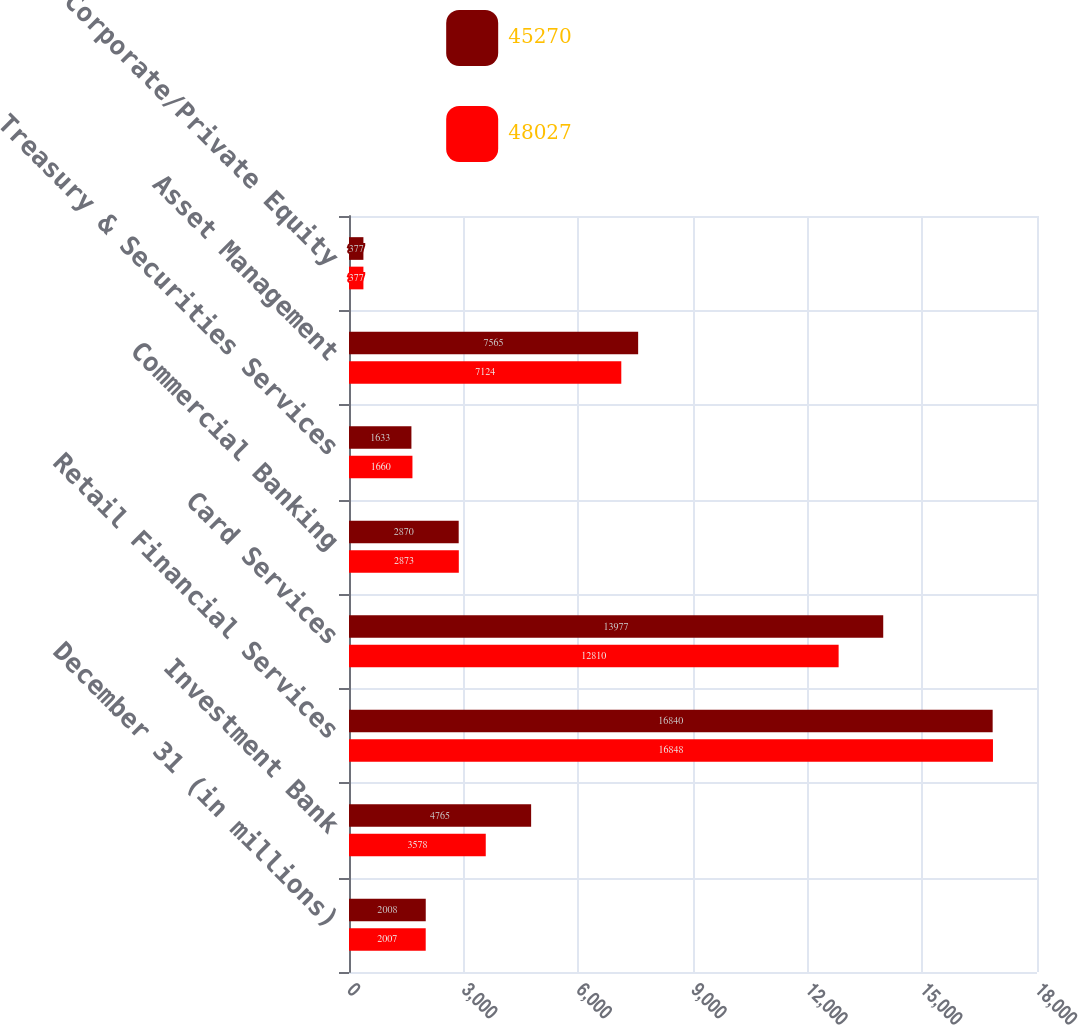Convert chart to OTSL. <chart><loc_0><loc_0><loc_500><loc_500><stacked_bar_chart><ecel><fcel>December 31 (in millions)<fcel>Investment Bank<fcel>Retail Financial Services<fcel>Card Services<fcel>Commercial Banking<fcel>Treasury & Securities Services<fcel>Asset Management<fcel>Corporate/Private Equity<nl><fcel>45270<fcel>2008<fcel>4765<fcel>16840<fcel>13977<fcel>2870<fcel>1633<fcel>7565<fcel>377<nl><fcel>48027<fcel>2007<fcel>3578<fcel>16848<fcel>12810<fcel>2873<fcel>1660<fcel>7124<fcel>377<nl></chart> 